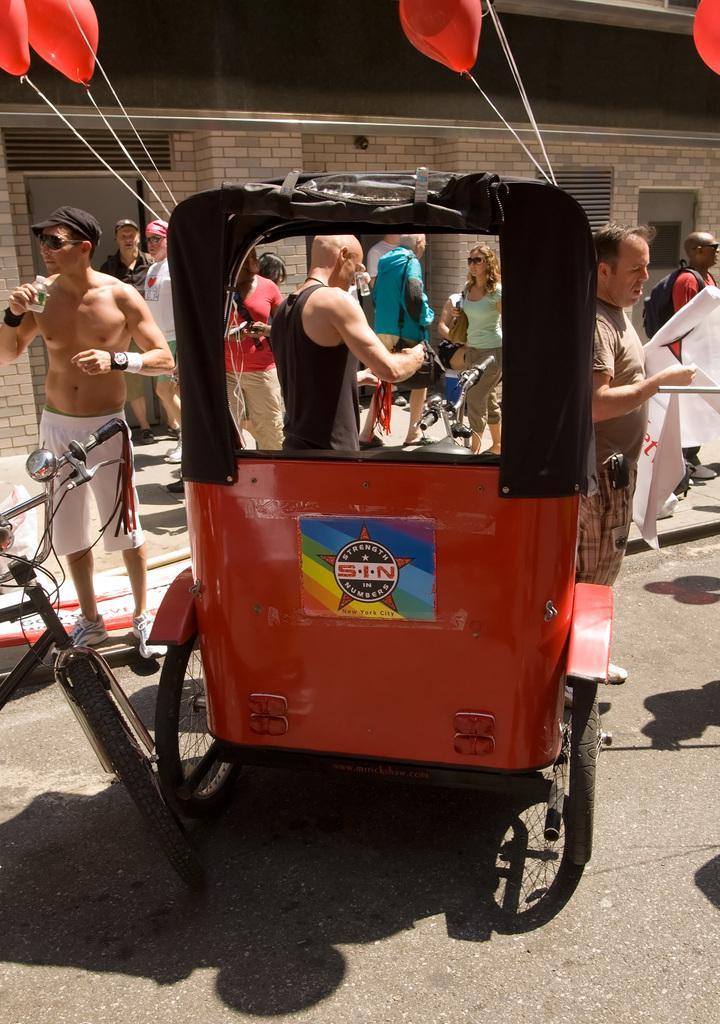Can you describe this image briefly? In this picture we can see a rickshaw and a bicycle on the path and the balloons are tied to the rickshaw. In front of the rickshaw there are some people standing and a man is holding a bottle and the other man is holding a banner. Behind the people there is a wall. 